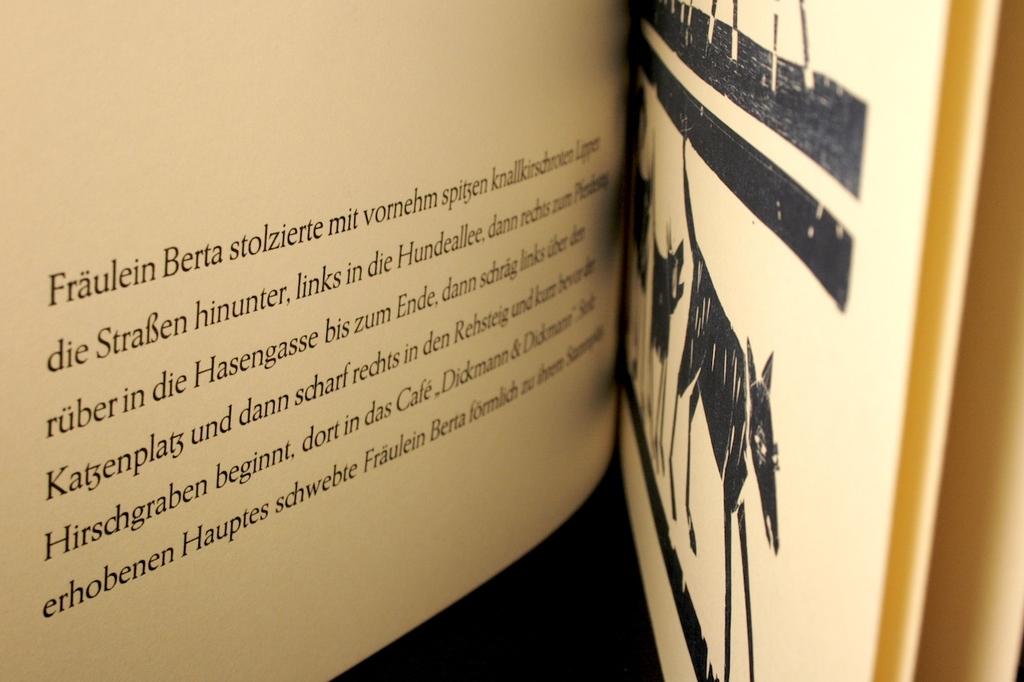What is the woman's name mentioned on this page?
Offer a terse response. Fraulein berta. 